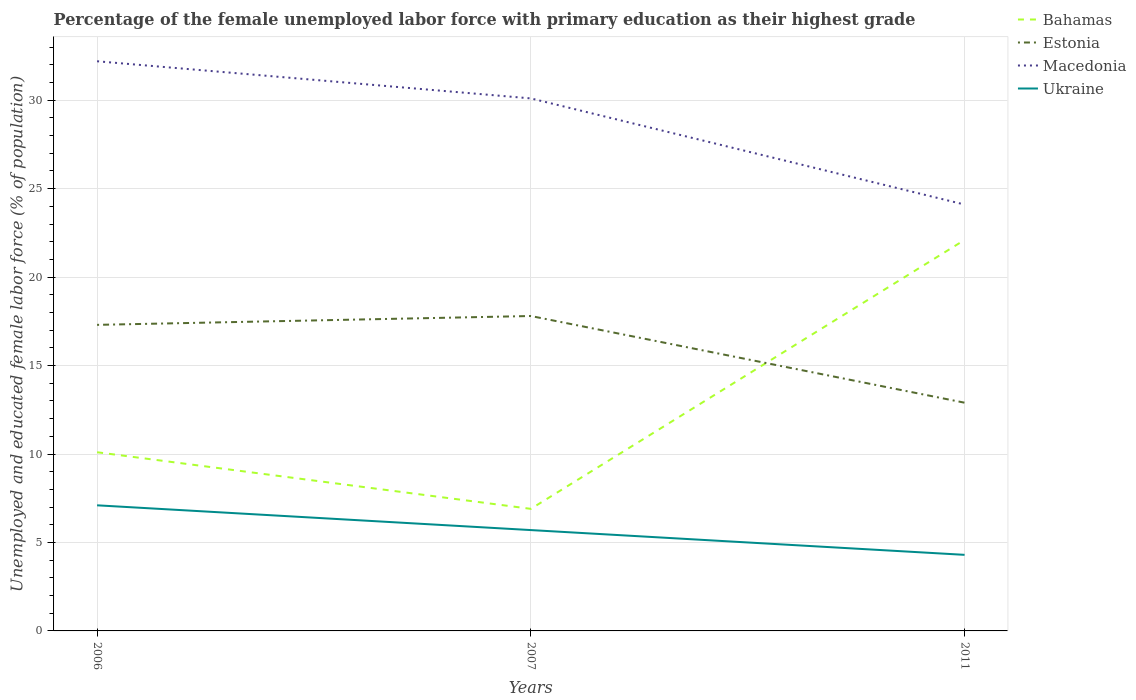How many different coloured lines are there?
Offer a very short reply. 4. Does the line corresponding to Ukraine intersect with the line corresponding to Estonia?
Keep it short and to the point. No. Across all years, what is the maximum percentage of the unemployed female labor force with primary education in Estonia?
Provide a short and direct response. 12.9. In which year was the percentage of the unemployed female labor force with primary education in Ukraine maximum?
Offer a very short reply. 2011. What is the total percentage of the unemployed female labor force with primary education in Ukraine in the graph?
Make the answer very short. 1.4. What is the difference between the highest and the second highest percentage of the unemployed female labor force with primary education in Bahamas?
Make the answer very short. 15.2. What is the difference between the highest and the lowest percentage of the unemployed female labor force with primary education in Macedonia?
Give a very brief answer. 2. Does the graph contain grids?
Give a very brief answer. Yes. How many legend labels are there?
Give a very brief answer. 4. How are the legend labels stacked?
Make the answer very short. Vertical. What is the title of the graph?
Ensure brevity in your answer.  Percentage of the female unemployed labor force with primary education as their highest grade. Does "Sri Lanka" appear as one of the legend labels in the graph?
Give a very brief answer. No. What is the label or title of the Y-axis?
Your answer should be compact. Unemployed and educated female labor force (% of population). What is the Unemployed and educated female labor force (% of population) in Bahamas in 2006?
Provide a short and direct response. 10.1. What is the Unemployed and educated female labor force (% of population) of Estonia in 2006?
Ensure brevity in your answer.  17.3. What is the Unemployed and educated female labor force (% of population) in Macedonia in 2006?
Give a very brief answer. 32.2. What is the Unemployed and educated female labor force (% of population) in Ukraine in 2006?
Your answer should be very brief. 7.1. What is the Unemployed and educated female labor force (% of population) in Bahamas in 2007?
Your answer should be very brief. 6.9. What is the Unemployed and educated female labor force (% of population) of Estonia in 2007?
Make the answer very short. 17.8. What is the Unemployed and educated female labor force (% of population) in Macedonia in 2007?
Offer a terse response. 30.1. What is the Unemployed and educated female labor force (% of population) of Ukraine in 2007?
Provide a short and direct response. 5.7. What is the Unemployed and educated female labor force (% of population) of Bahamas in 2011?
Give a very brief answer. 22.1. What is the Unemployed and educated female labor force (% of population) of Estonia in 2011?
Offer a terse response. 12.9. What is the Unemployed and educated female labor force (% of population) in Macedonia in 2011?
Provide a short and direct response. 24.1. What is the Unemployed and educated female labor force (% of population) in Ukraine in 2011?
Provide a short and direct response. 4.3. Across all years, what is the maximum Unemployed and educated female labor force (% of population) of Bahamas?
Your answer should be very brief. 22.1. Across all years, what is the maximum Unemployed and educated female labor force (% of population) of Estonia?
Ensure brevity in your answer.  17.8. Across all years, what is the maximum Unemployed and educated female labor force (% of population) in Macedonia?
Your answer should be compact. 32.2. Across all years, what is the maximum Unemployed and educated female labor force (% of population) of Ukraine?
Provide a short and direct response. 7.1. Across all years, what is the minimum Unemployed and educated female labor force (% of population) in Bahamas?
Provide a succinct answer. 6.9. Across all years, what is the minimum Unemployed and educated female labor force (% of population) of Estonia?
Keep it short and to the point. 12.9. Across all years, what is the minimum Unemployed and educated female labor force (% of population) of Macedonia?
Your answer should be very brief. 24.1. Across all years, what is the minimum Unemployed and educated female labor force (% of population) of Ukraine?
Your response must be concise. 4.3. What is the total Unemployed and educated female labor force (% of population) of Bahamas in the graph?
Make the answer very short. 39.1. What is the total Unemployed and educated female labor force (% of population) of Estonia in the graph?
Your response must be concise. 48. What is the total Unemployed and educated female labor force (% of population) of Macedonia in the graph?
Ensure brevity in your answer.  86.4. What is the difference between the Unemployed and educated female labor force (% of population) in Bahamas in 2006 and that in 2007?
Your answer should be very brief. 3.2. What is the difference between the Unemployed and educated female labor force (% of population) of Macedonia in 2006 and that in 2007?
Provide a short and direct response. 2.1. What is the difference between the Unemployed and educated female labor force (% of population) in Bahamas in 2007 and that in 2011?
Offer a terse response. -15.2. What is the difference between the Unemployed and educated female labor force (% of population) in Ukraine in 2007 and that in 2011?
Offer a terse response. 1.4. What is the difference between the Unemployed and educated female labor force (% of population) of Bahamas in 2006 and the Unemployed and educated female labor force (% of population) of Ukraine in 2007?
Provide a short and direct response. 4.4. What is the difference between the Unemployed and educated female labor force (% of population) in Estonia in 2006 and the Unemployed and educated female labor force (% of population) in Ukraine in 2007?
Offer a terse response. 11.6. What is the difference between the Unemployed and educated female labor force (% of population) in Macedonia in 2006 and the Unemployed and educated female labor force (% of population) in Ukraine in 2007?
Make the answer very short. 26.5. What is the difference between the Unemployed and educated female labor force (% of population) of Bahamas in 2006 and the Unemployed and educated female labor force (% of population) of Estonia in 2011?
Provide a short and direct response. -2.8. What is the difference between the Unemployed and educated female labor force (% of population) in Estonia in 2006 and the Unemployed and educated female labor force (% of population) in Ukraine in 2011?
Make the answer very short. 13. What is the difference between the Unemployed and educated female labor force (% of population) in Macedonia in 2006 and the Unemployed and educated female labor force (% of population) in Ukraine in 2011?
Give a very brief answer. 27.9. What is the difference between the Unemployed and educated female labor force (% of population) in Bahamas in 2007 and the Unemployed and educated female labor force (% of population) in Macedonia in 2011?
Provide a succinct answer. -17.2. What is the difference between the Unemployed and educated female labor force (% of population) of Bahamas in 2007 and the Unemployed and educated female labor force (% of population) of Ukraine in 2011?
Make the answer very short. 2.6. What is the difference between the Unemployed and educated female labor force (% of population) of Estonia in 2007 and the Unemployed and educated female labor force (% of population) of Ukraine in 2011?
Keep it short and to the point. 13.5. What is the difference between the Unemployed and educated female labor force (% of population) in Macedonia in 2007 and the Unemployed and educated female labor force (% of population) in Ukraine in 2011?
Your response must be concise. 25.8. What is the average Unemployed and educated female labor force (% of population) of Bahamas per year?
Your response must be concise. 13.03. What is the average Unemployed and educated female labor force (% of population) of Estonia per year?
Keep it short and to the point. 16. What is the average Unemployed and educated female labor force (% of population) in Macedonia per year?
Your response must be concise. 28.8. What is the average Unemployed and educated female labor force (% of population) in Ukraine per year?
Give a very brief answer. 5.7. In the year 2006, what is the difference between the Unemployed and educated female labor force (% of population) of Bahamas and Unemployed and educated female labor force (% of population) of Macedonia?
Keep it short and to the point. -22.1. In the year 2006, what is the difference between the Unemployed and educated female labor force (% of population) in Estonia and Unemployed and educated female labor force (% of population) in Macedonia?
Your answer should be compact. -14.9. In the year 2006, what is the difference between the Unemployed and educated female labor force (% of population) in Macedonia and Unemployed and educated female labor force (% of population) in Ukraine?
Offer a very short reply. 25.1. In the year 2007, what is the difference between the Unemployed and educated female labor force (% of population) in Bahamas and Unemployed and educated female labor force (% of population) in Macedonia?
Your answer should be very brief. -23.2. In the year 2007, what is the difference between the Unemployed and educated female labor force (% of population) of Bahamas and Unemployed and educated female labor force (% of population) of Ukraine?
Offer a very short reply. 1.2. In the year 2007, what is the difference between the Unemployed and educated female labor force (% of population) of Estonia and Unemployed and educated female labor force (% of population) of Ukraine?
Your answer should be compact. 12.1. In the year 2007, what is the difference between the Unemployed and educated female labor force (% of population) of Macedonia and Unemployed and educated female labor force (% of population) of Ukraine?
Ensure brevity in your answer.  24.4. In the year 2011, what is the difference between the Unemployed and educated female labor force (% of population) in Bahamas and Unemployed and educated female labor force (% of population) in Macedonia?
Offer a very short reply. -2. In the year 2011, what is the difference between the Unemployed and educated female labor force (% of population) of Bahamas and Unemployed and educated female labor force (% of population) of Ukraine?
Your answer should be very brief. 17.8. In the year 2011, what is the difference between the Unemployed and educated female labor force (% of population) in Estonia and Unemployed and educated female labor force (% of population) in Ukraine?
Your answer should be very brief. 8.6. In the year 2011, what is the difference between the Unemployed and educated female labor force (% of population) of Macedonia and Unemployed and educated female labor force (% of population) of Ukraine?
Keep it short and to the point. 19.8. What is the ratio of the Unemployed and educated female labor force (% of population) in Bahamas in 2006 to that in 2007?
Your answer should be very brief. 1.46. What is the ratio of the Unemployed and educated female labor force (% of population) in Estonia in 2006 to that in 2007?
Your answer should be very brief. 0.97. What is the ratio of the Unemployed and educated female labor force (% of population) of Macedonia in 2006 to that in 2007?
Your answer should be very brief. 1.07. What is the ratio of the Unemployed and educated female labor force (% of population) of Ukraine in 2006 to that in 2007?
Ensure brevity in your answer.  1.25. What is the ratio of the Unemployed and educated female labor force (% of population) of Bahamas in 2006 to that in 2011?
Offer a terse response. 0.46. What is the ratio of the Unemployed and educated female labor force (% of population) in Estonia in 2006 to that in 2011?
Your answer should be very brief. 1.34. What is the ratio of the Unemployed and educated female labor force (% of population) in Macedonia in 2006 to that in 2011?
Your response must be concise. 1.34. What is the ratio of the Unemployed and educated female labor force (% of population) of Ukraine in 2006 to that in 2011?
Your answer should be compact. 1.65. What is the ratio of the Unemployed and educated female labor force (% of population) of Bahamas in 2007 to that in 2011?
Your answer should be very brief. 0.31. What is the ratio of the Unemployed and educated female labor force (% of population) in Estonia in 2007 to that in 2011?
Give a very brief answer. 1.38. What is the ratio of the Unemployed and educated female labor force (% of population) of Macedonia in 2007 to that in 2011?
Provide a succinct answer. 1.25. What is the ratio of the Unemployed and educated female labor force (% of population) in Ukraine in 2007 to that in 2011?
Your response must be concise. 1.33. What is the difference between the highest and the second highest Unemployed and educated female labor force (% of population) in Macedonia?
Your response must be concise. 2.1. What is the difference between the highest and the lowest Unemployed and educated female labor force (% of population) of Bahamas?
Your answer should be very brief. 15.2. What is the difference between the highest and the lowest Unemployed and educated female labor force (% of population) in Estonia?
Your answer should be very brief. 4.9. What is the difference between the highest and the lowest Unemployed and educated female labor force (% of population) of Macedonia?
Offer a terse response. 8.1. 